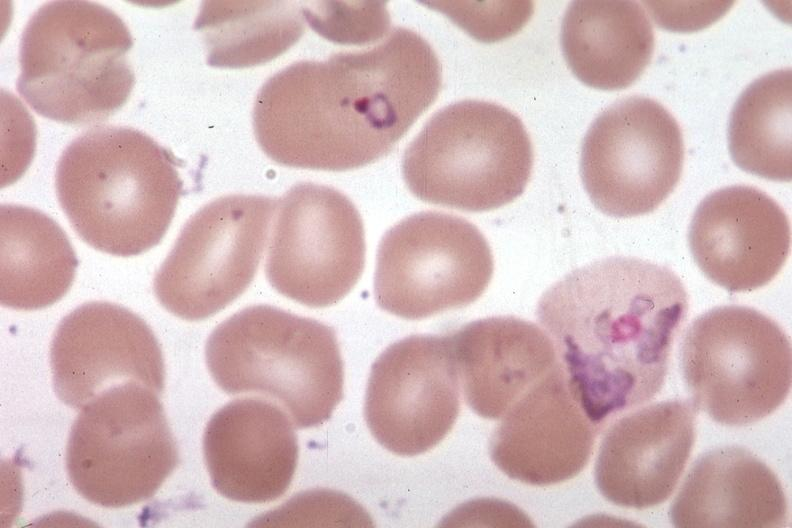s aorta present?
Answer the question using a single word or phrase. No 